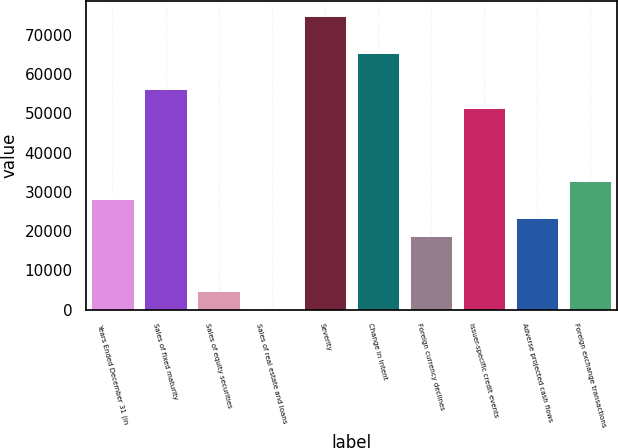<chart> <loc_0><loc_0><loc_500><loc_500><bar_chart><fcel>Years Ended December 31 (in<fcel>Sales of fixed maturity<fcel>Sales of equity securities<fcel>Sales of real estate and loans<fcel>Severity<fcel>Change in intent<fcel>Foreign currency declines<fcel>Issuer-specific credit events<fcel>Adverse projected cash flows<fcel>Foreign exchange transactions<nl><fcel>28130.8<fcel>56125.6<fcel>4801.8<fcel>136<fcel>74788.8<fcel>65457.2<fcel>18799.2<fcel>51459.8<fcel>23465<fcel>32796.6<nl></chart> 